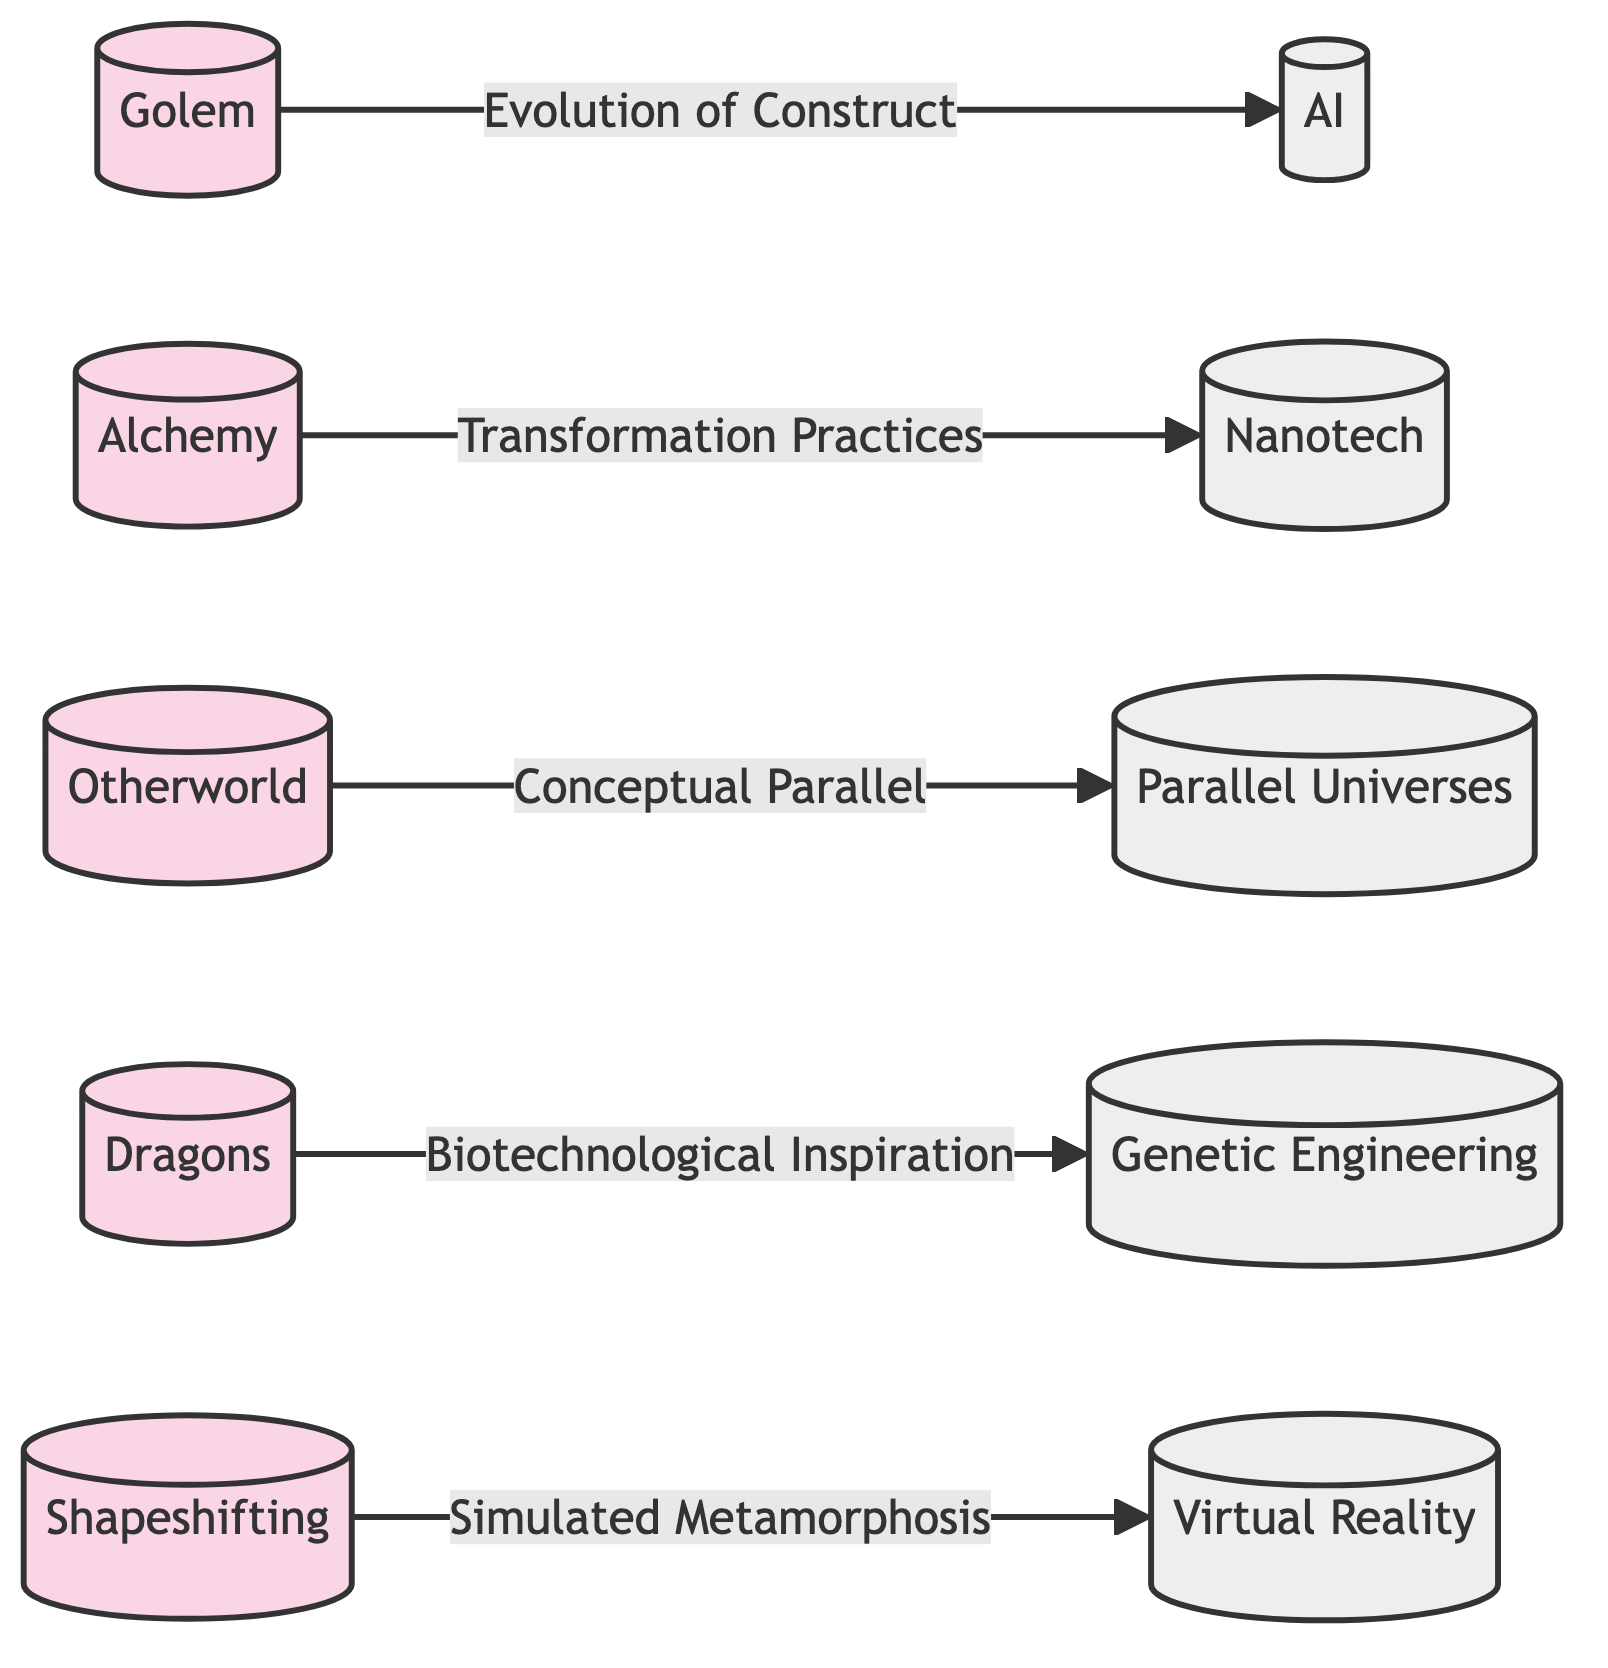What is the first folklore entity listed? The diagram lists "Golem" as the first folklore entity represented by node 1.
Answer: Golem How many nodes are there in the diagram? The diagram features a total of 10 nodes, which represent various folklore and sci-fi elements.
Answer: 10 What is the relationship between Golem and Artificial Intelligence? The edge connecting these two nodes is labeled "Evolution of Construct," indicating how the concept of a Golem relates to advancements in AI.
Answer: Evolution of Construct Which folklore element is linked to Nanotechnology? The diagram shows that "Alchemy" is connected to "Nanotechnology" through the relationship labeled "Transformation Practices."
Answer: Alchemy How many edges are connecting folklore elements to sci-fi technologies? There are 5 edges in total connecting the folklore elements to various sci-fi technologies as depicted in the diagram.
Answer: 5 What concept does Otherworld connect to in the diagram? The "Otherworld" node is linked to "Parallel Universes" under the relationship "Conceptual Parallel," suggesting a thematic connection between these two concepts.
Answer: Parallel Universes Which folklore motif is associated with Virtual Reality? According to the diagram, "Shapeshifting" is directly associated with "Virtual Reality" through the relationship labeled "Simulated Metamorphosis."
Answer: Shapeshifting Which folklore myth is linked to Genetic Engineering? The diagram indicates that "Dragons" are connected to "Genetic Engineering" through the relationship labeled "Biotechnological Inspiration," representing a thematic intertwining.
Answer: Dragons What type of graph structures these relationships? The diagram is structured as a directed graph, emphasizing directed relationships between folklore and sci-fi entities.
Answer: Directed Graph How is Alchemy related to modern applications? The diagram illustrates the connection between "Alchemy" and "Nanotechnology" through the relationship defined as "Transformation Practices."
Answer: Transformation Practices 